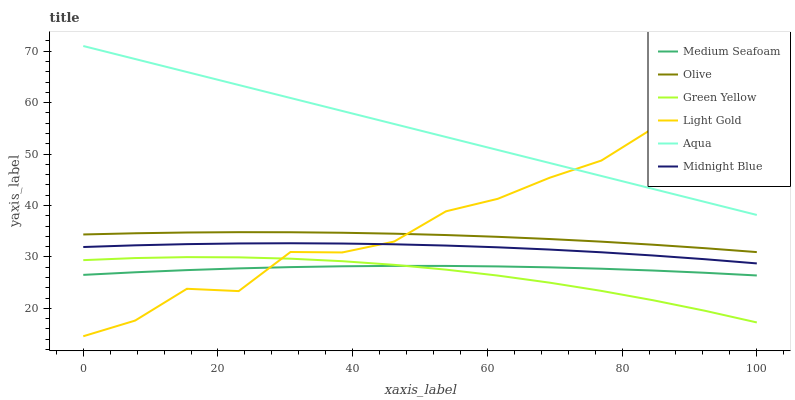Does Green Yellow have the minimum area under the curve?
Answer yes or no. Yes. Does Aqua have the maximum area under the curve?
Answer yes or no. Yes. Does Olive have the minimum area under the curve?
Answer yes or no. No. Does Olive have the maximum area under the curve?
Answer yes or no. No. Is Aqua the smoothest?
Answer yes or no. Yes. Is Light Gold the roughest?
Answer yes or no. Yes. Is Olive the smoothest?
Answer yes or no. No. Is Olive the roughest?
Answer yes or no. No. Does Olive have the lowest value?
Answer yes or no. No. Does Olive have the highest value?
Answer yes or no. No. Is Green Yellow less than Aqua?
Answer yes or no. Yes. Is Aqua greater than Midnight Blue?
Answer yes or no. Yes. Does Green Yellow intersect Aqua?
Answer yes or no. No. 